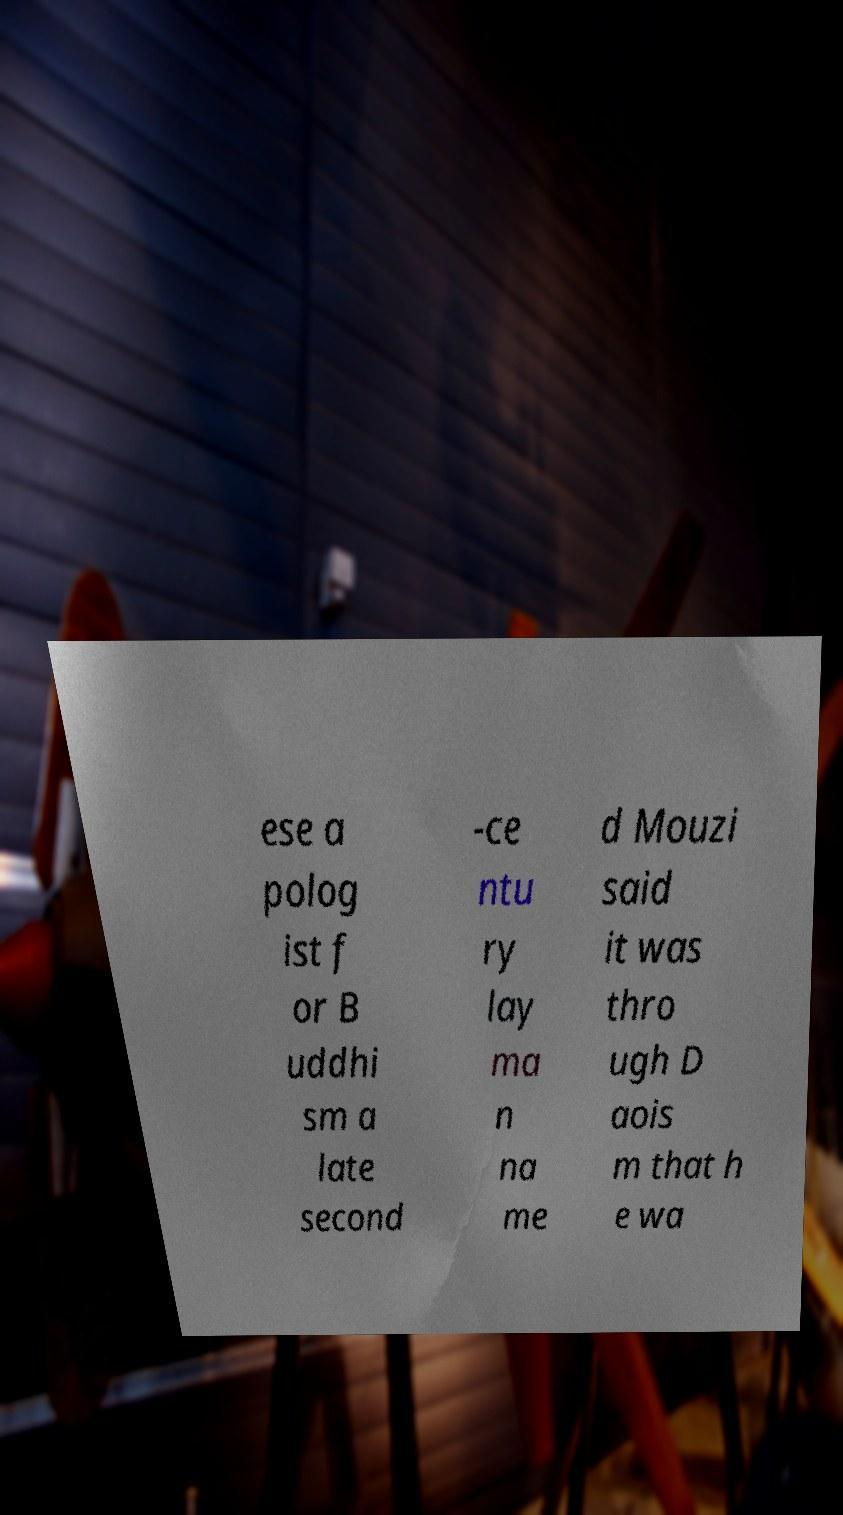Please identify and transcribe the text found in this image. ese a polog ist f or B uddhi sm a late second -ce ntu ry lay ma n na me d Mouzi said it was thro ugh D aois m that h e wa 